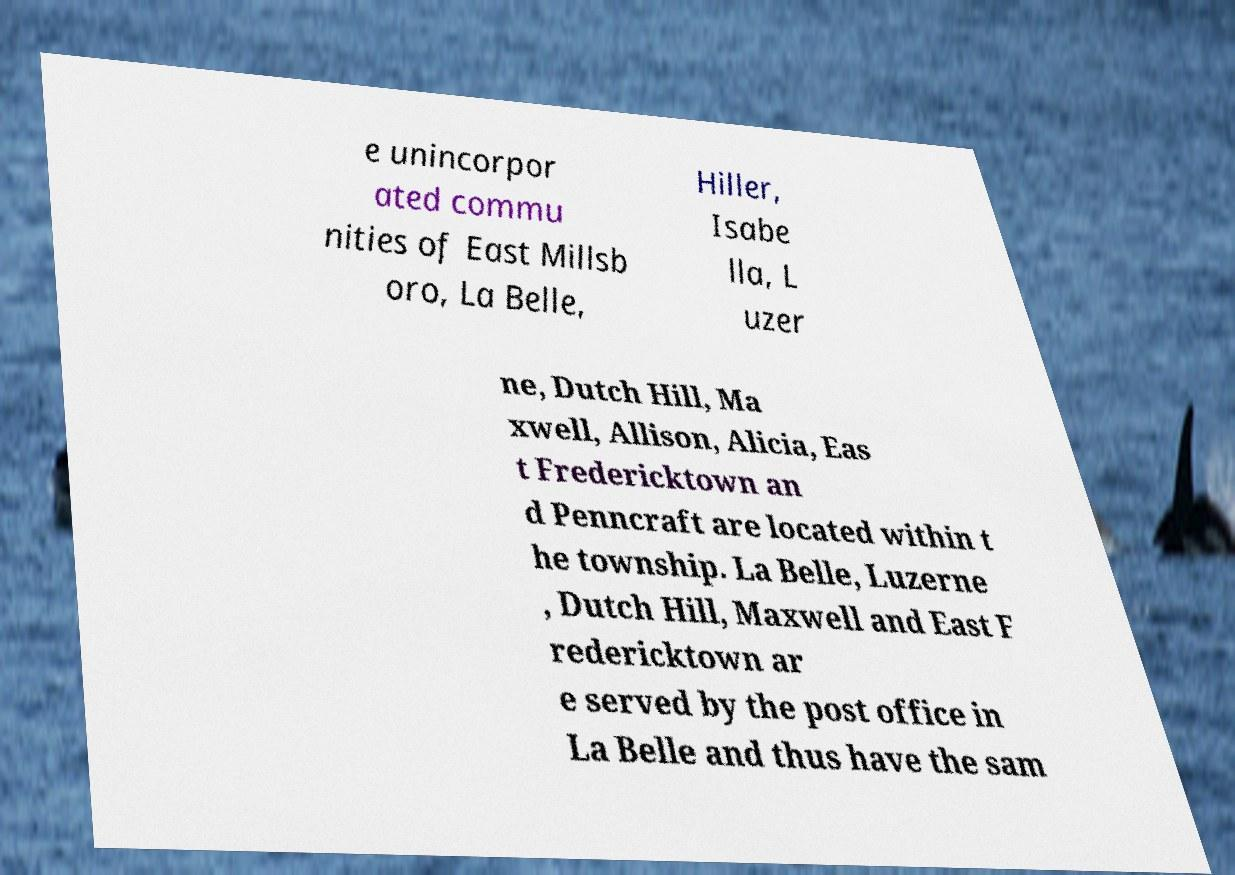I need the written content from this picture converted into text. Can you do that? e unincorpor ated commu nities of East Millsb oro, La Belle, Hiller, Isabe lla, L uzer ne, Dutch Hill, Ma xwell, Allison, Alicia, Eas t Fredericktown an d Penncraft are located within t he township. La Belle, Luzerne , Dutch Hill, Maxwell and East F redericktown ar e served by the post office in La Belle and thus have the sam 